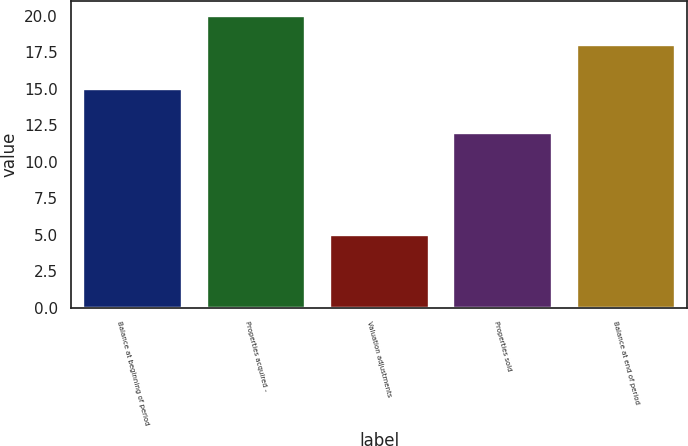Convert chart to OTSL. <chart><loc_0><loc_0><loc_500><loc_500><bar_chart><fcel>Balance at beginning of period<fcel>Properties acquired -<fcel>Valuation adjustments<fcel>Properties sold<fcel>Balance at end of period<nl><fcel>15<fcel>20<fcel>5<fcel>12<fcel>18<nl></chart> 